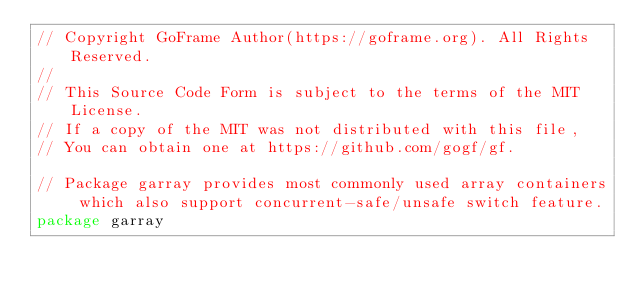Convert code to text. <code><loc_0><loc_0><loc_500><loc_500><_Go_>// Copyright GoFrame Author(https://goframe.org). All Rights Reserved.
//
// This Source Code Form is subject to the terms of the MIT License.
// If a copy of the MIT was not distributed with this file,
// You can obtain one at https://github.com/gogf/gf.

// Package garray provides most commonly used array containers which also support concurrent-safe/unsafe switch feature.
package garray
</code> 